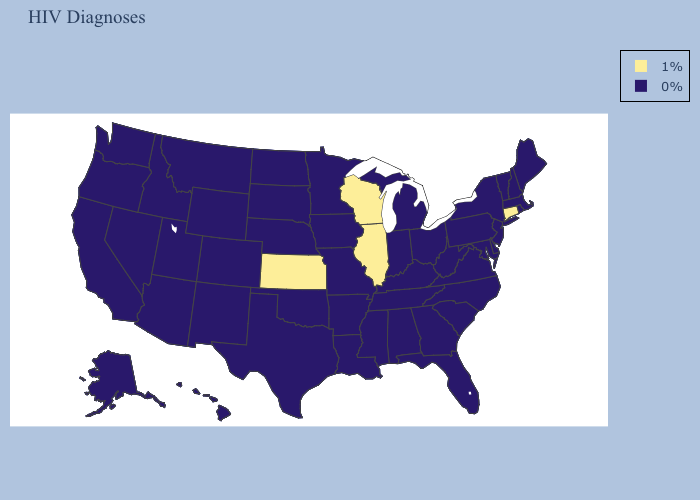What is the value of Arkansas?
Quick response, please. 0%. Does Connecticut have the highest value in the USA?
Be succinct. Yes. What is the lowest value in the USA?
Keep it brief. 0%. What is the lowest value in states that border Michigan?
Answer briefly. 0%. What is the value of Oklahoma?
Concise answer only. 0%. Does the map have missing data?
Short answer required. No. How many symbols are there in the legend?
Short answer required. 2. What is the value of Hawaii?
Quick response, please. 0%. Name the states that have a value in the range 0%?
Be succinct. Alabama, Alaska, Arizona, Arkansas, California, Colorado, Delaware, Florida, Georgia, Hawaii, Idaho, Indiana, Iowa, Kentucky, Louisiana, Maine, Maryland, Massachusetts, Michigan, Minnesota, Mississippi, Missouri, Montana, Nebraska, Nevada, New Hampshire, New Jersey, New Mexico, New York, North Carolina, North Dakota, Ohio, Oklahoma, Oregon, Pennsylvania, Rhode Island, South Carolina, South Dakota, Tennessee, Texas, Utah, Vermont, Virginia, Washington, West Virginia, Wyoming. Which states have the lowest value in the USA?
Quick response, please. Alabama, Alaska, Arizona, Arkansas, California, Colorado, Delaware, Florida, Georgia, Hawaii, Idaho, Indiana, Iowa, Kentucky, Louisiana, Maine, Maryland, Massachusetts, Michigan, Minnesota, Mississippi, Missouri, Montana, Nebraska, Nevada, New Hampshire, New Jersey, New Mexico, New York, North Carolina, North Dakota, Ohio, Oklahoma, Oregon, Pennsylvania, Rhode Island, South Carolina, South Dakota, Tennessee, Texas, Utah, Vermont, Virginia, Washington, West Virginia, Wyoming. Which states have the lowest value in the MidWest?
Short answer required. Indiana, Iowa, Michigan, Minnesota, Missouri, Nebraska, North Dakota, Ohio, South Dakota. Does the map have missing data?
Answer briefly. No. Name the states that have a value in the range 0%?
Give a very brief answer. Alabama, Alaska, Arizona, Arkansas, California, Colorado, Delaware, Florida, Georgia, Hawaii, Idaho, Indiana, Iowa, Kentucky, Louisiana, Maine, Maryland, Massachusetts, Michigan, Minnesota, Mississippi, Missouri, Montana, Nebraska, Nevada, New Hampshire, New Jersey, New Mexico, New York, North Carolina, North Dakota, Ohio, Oklahoma, Oregon, Pennsylvania, Rhode Island, South Carolina, South Dakota, Tennessee, Texas, Utah, Vermont, Virginia, Washington, West Virginia, Wyoming. Which states have the lowest value in the Northeast?
Concise answer only. Maine, Massachusetts, New Hampshire, New Jersey, New York, Pennsylvania, Rhode Island, Vermont. What is the lowest value in the USA?
Quick response, please. 0%. 